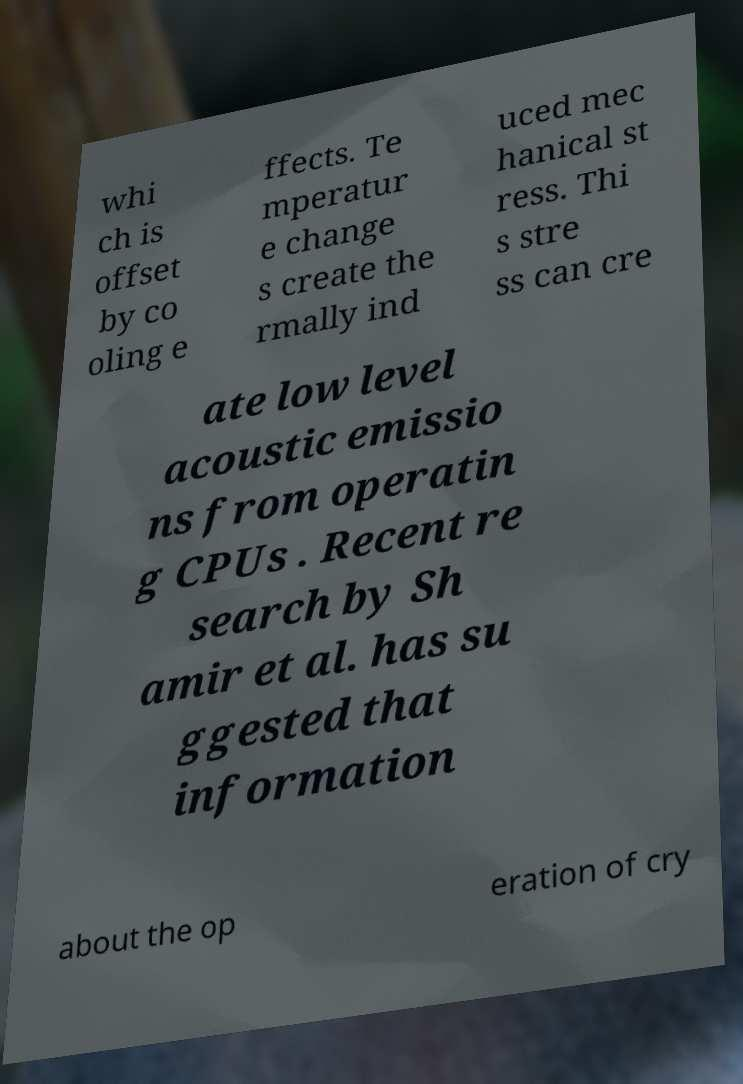Can you read and provide the text displayed in the image?This photo seems to have some interesting text. Can you extract and type it out for me? whi ch is offset by co oling e ffects. Te mperatur e change s create the rmally ind uced mec hanical st ress. Thi s stre ss can cre ate low level acoustic emissio ns from operatin g CPUs . Recent re search by Sh amir et al. has su ggested that information about the op eration of cry 